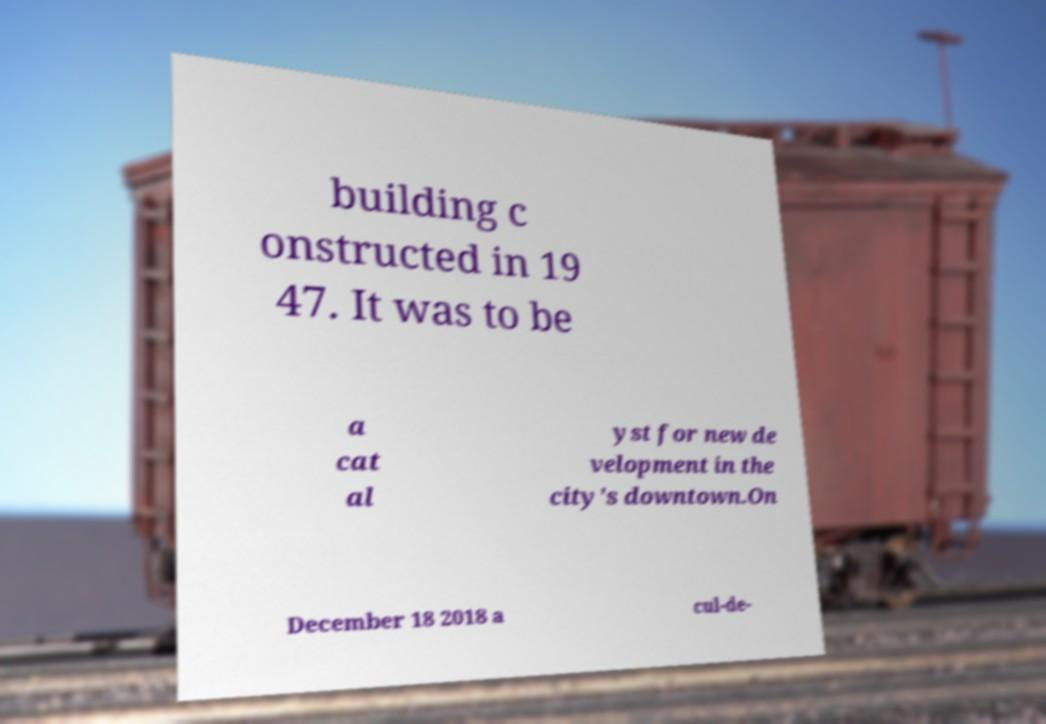I need the written content from this picture converted into text. Can you do that? building c onstructed in 19 47. It was to be a cat al yst for new de velopment in the city's downtown.On December 18 2018 a cul-de- 